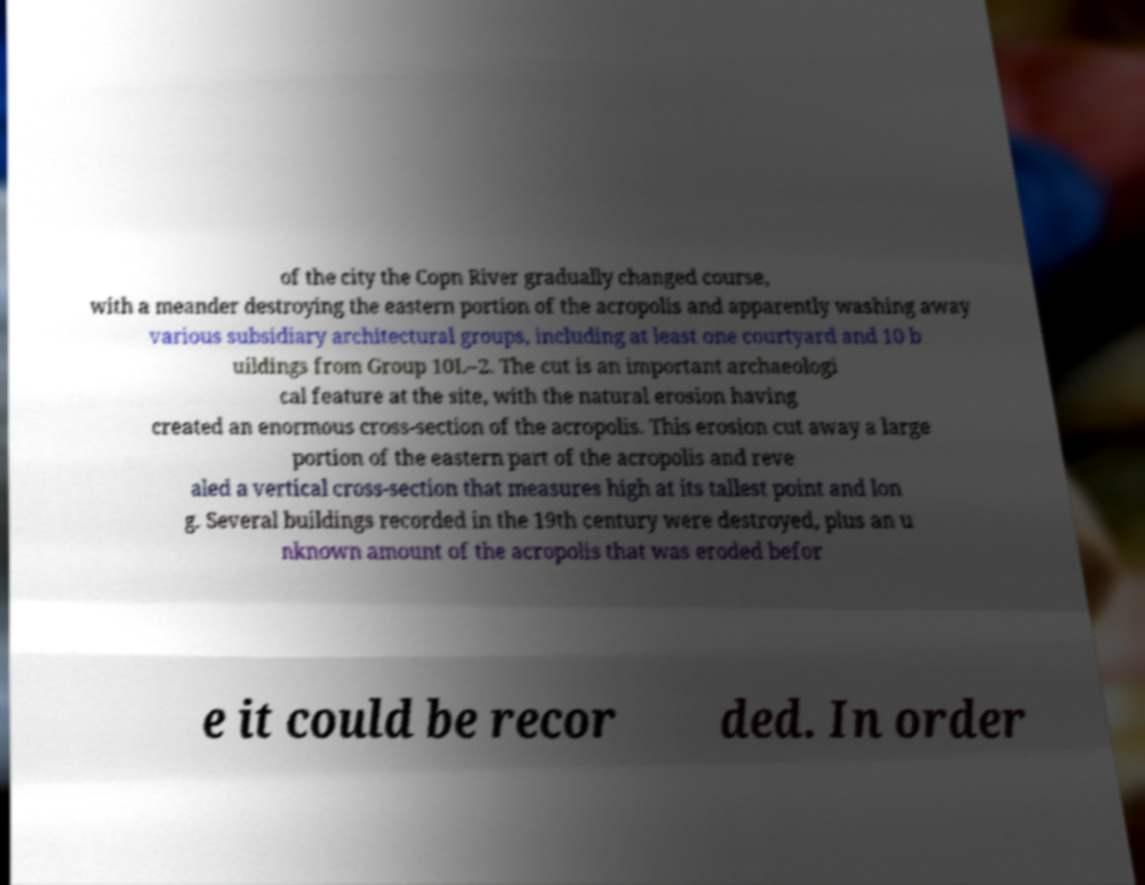Please read and relay the text visible in this image. What does it say? of the city the Copn River gradually changed course, with a meander destroying the eastern portion of the acropolis and apparently washing away various subsidiary architectural groups, including at least one courtyard and 10 b uildings from Group 10L–2. The cut is an important archaeologi cal feature at the site, with the natural erosion having created an enormous cross-section of the acropolis. This erosion cut away a large portion of the eastern part of the acropolis and reve aled a vertical cross-section that measures high at its tallest point and lon g. Several buildings recorded in the 19th century were destroyed, plus an u nknown amount of the acropolis that was eroded befor e it could be recor ded. In order 